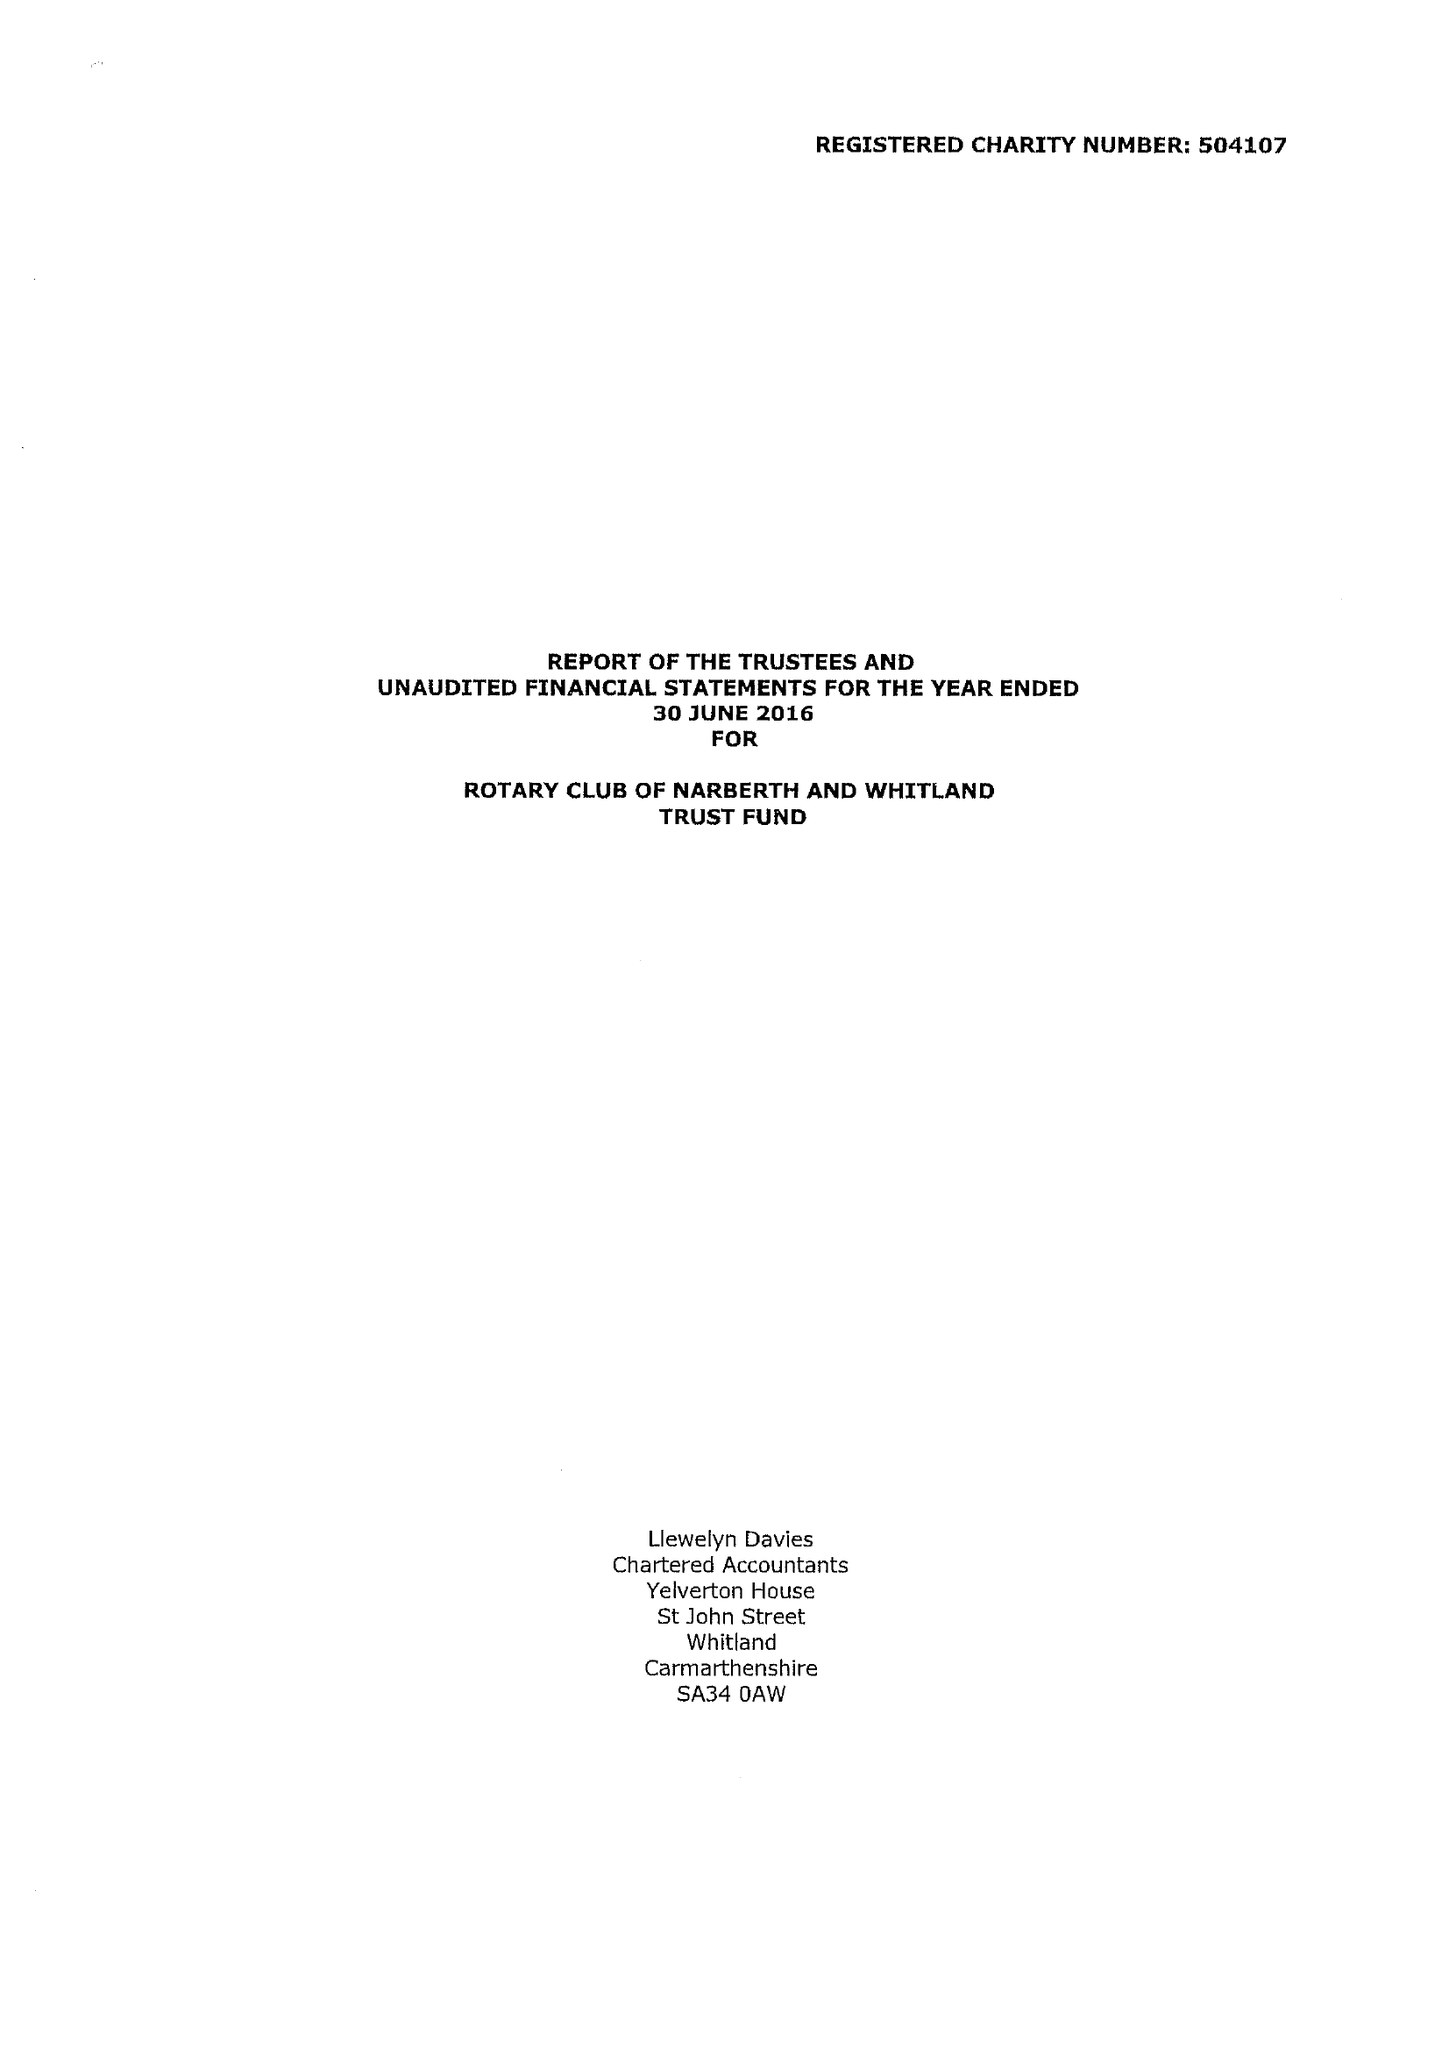What is the value for the income_annually_in_british_pounds?
Answer the question using a single word or phrase. 50137.00 